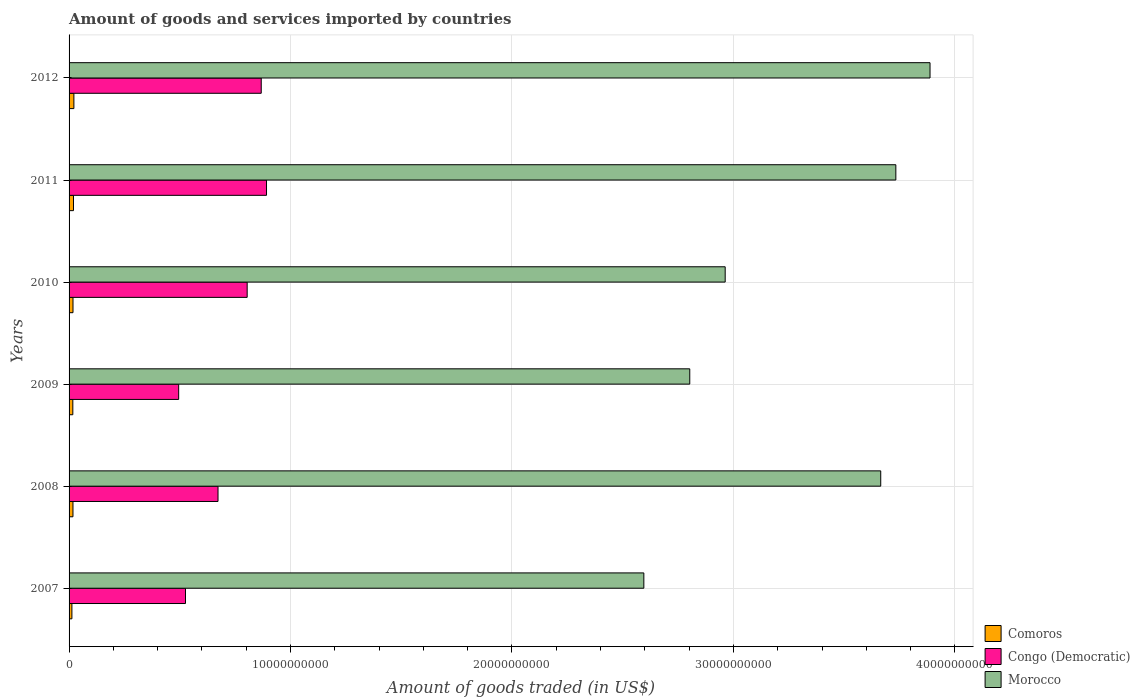Are the number of bars per tick equal to the number of legend labels?
Offer a terse response. Yes. Are the number of bars on each tick of the Y-axis equal?
Offer a very short reply. Yes. How many bars are there on the 5th tick from the bottom?
Your answer should be very brief. 3. In how many cases, is the number of bars for a given year not equal to the number of legend labels?
Give a very brief answer. 0. What is the total amount of goods and services imported in Comoros in 2012?
Make the answer very short. 2.18e+08. Across all years, what is the maximum total amount of goods and services imported in Comoros?
Your answer should be very brief. 2.18e+08. Across all years, what is the minimum total amount of goods and services imported in Morocco?
Offer a very short reply. 2.60e+1. In which year was the total amount of goods and services imported in Congo (Democratic) minimum?
Offer a terse response. 2009. What is the total total amount of goods and services imported in Morocco in the graph?
Your answer should be very brief. 1.96e+11. What is the difference between the total amount of goods and services imported in Morocco in 2009 and that in 2011?
Your answer should be very brief. -9.31e+09. What is the difference between the total amount of goods and services imported in Congo (Democratic) in 2009 and the total amount of goods and services imported in Comoros in 2008?
Offer a very short reply. 4.77e+09. What is the average total amount of goods and services imported in Morocco per year?
Ensure brevity in your answer.  3.27e+1. In the year 2011, what is the difference between the total amount of goods and services imported in Congo (Democratic) and total amount of goods and services imported in Morocco?
Provide a succinct answer. -2.84e+1. In how many years, is the total amount of goods and services imported in Morocco greater than 14000000000 US$?
Ensure brevity in your answer.  6. What is the ratio of the total amount of goods and services imported in Morocco in 2009 to that in 2010?
Make the answer very short. 0.95. What is the difference between the highest and the second highest total amount of goods and services imported in Congo (Democratic)?
Ensure brevity in your answer.  2.38e+08. What is the difference between the highest and the lowest total amount of goods and services imported in Morocco?
Your response must be concise. 1.29e+1. In how many years, is the total amount of goods and services imported in Morocco greater than the average total amount of goods and services imported in Morocco taken over all years?
Ensure brevity in your answer.  3. What does the 2nd bar from the top in 2012 represents?
Your answer should be very brief. Congo (Democratic). What does the 1st bar from the bottom in 2008 represents?
Keep it short and to the point. Comoros. How many bars are there?
Your answer should be very brief. 18. Are the values on the major ticks of X-axis written in scientific E-notation?
Offer a terse response. No. Does the graph contain any zero values?
Provide a short and direct response. No. Does the graph contain grids?
Keep it short and to the point. Yes. How many legend labels are there?
Give a very brief answer. 3. How are the legend labels stacked?
Offer a terse response. Vertical. What is the title of the graph?
Make the answer very short. Amount of goods and services imported by countries. What is the label or title of the X-axis?
Offer a very short reply. Amount of goods traded (in US$). What is the Amount of goods traded (in US$) in Comoros in 2007?
Your response must be concise. 1.28e+08. What is the Amount of goods traded (in US$) of Congo (Democratic) in 2007?
Keep it short and to the point. 5.26e+09. What is the Amount of goods traded (in US$) in Morocco in 2007?
Your response must be concise. 2.60e+1. What is the Amount of goods traded (in US$) in Comoros in 2008?
Your answer should be compact. 1.76e+08. What is the Amount of goods traded (in US$) of Congo (Democratic) in 2008?
Your response must be concise. 6.73e+09. What is the Amount of goods traded (in US$) in Morocco in 2008?
Your answer should be very brief. 3.67e+1. What is the Amount of goods traded (in US$) of Comoros in 2009?
Offer a terse response. 1.70e+08. What is the Amount of goods traded (in US$) in Congo (Democratic) in 2009?
Offer a very short reply. 4.95e+09. What is the Amount of goods traded (in US$) in Morocco in 2009?
Keep it short and to the point. 2.80e+1. What is the Amount of goods traded (in US$) in Comoros in 2010?
Offer a terse response. 1.77e+08. What is the Amount of goods traded (in US$) in Congo (Democratic) in 2010?
Provide a short and direct response. 8.04e+09. What is the Amount of goods traded (in US$) in Morocco in 2010?
Make the answer very short. 2.96e+1. What is the Amount of goods traded (in US$) in Comoros in 2011?
Ensure brevity in your answer.  1.99e+08. What is the Amount of goods traded (in US$) in Congo (Democratic) in 2011?
Offer a terse response. 8.92e+09. What is the Amount of goods traded (in US$) in Morocco in 2011?
Your answer should be compact. 3.73e+1. What is the Amount of goods traded (in US$) in Comoros in 2012?
Your answer should be compact. 2.18e+08. What is the Amount of goods traded (in US$) of Congo (Democratic) in 2012?
Your response must be concise. 8.68e+09. What is the Amount of goods traded (in US$) in Morocco in 2012?
Offer a terse response. 3.89e+1. Across all years, what is the maximum Amount of goods traded (in US$) of Comoros?
Offer a terse response. 2.18e+08. Across all years, what is the maximum Amount of goods traded (in US$) of Congo (Democratic)?
Provide a short and direct response. 8.92e+09. Across all years, what is the maximum Amount of goods traded (in US$) in Morocco?
Keep it short and to the point. 3.89e+1. Across all years, what is the minimum Amount of goods traded (in US$) of Comoros?
Provide a succinct answer. 1.28e+08. Across all years, what is the minimum Amount of goods traded (in US$) in Congo (Democratic)?
Provide a short and direct response. 4.95e+09. Across all years, what is the minimum Amount of goods traded (in US$) in Morocco?
Make the answer very short. 2.60e+1. What is the total Amount of goods traded (in US$) in Comoros in the graph?
Provide a succinct answer. 1.07e+09. What is the total Amount of goods traded (in US$) in Congo (Democratic) in the graph?
Offer a very short reply. 4.26e+1. What is the total Amount of goods traded (in US$) in Morocco in the graph?
Offer a very short reply. 1.96e+11. What is the difference between the Amount of goods traded (in US$) of Comoros in 2007 and that in 2008?
Give a very brief answer. -4.80e+07. What is the difference between the Amount of goods traded (in US$) of Congo (Democratic) in 2007 and that in 2008?
Provide a succinct answer. -1.47e+09. What is the difference between the Amount of goods traded (in US$) in Morocco in 2007 and that in 2008?
Ensure brevity in your answer.  -1.07e+1. What is the difference between the Amount of goods traded (in US$) in Comoros in 2007 and that in 2009?
Your answer should be compact. -4.17e+07. What is the difference between the Amount of goods traded (in US$) of Congo (Democratic) in 2007 and that in 2009?
Give a very brief answer. 3.08e+08. What is the difference between the Amount of goods traded (in US$) of Morocco in 2007 and that in 2009?
Offer a very short reply. -2.07e+09. What is the difference between the Amount of goods traded (in US$) in Comoros in 2007 and that in 2010?
Offer a terse response. -4.95e+07. What is the difference between the Amount of goods traded (in US$) in Congo (Democratic) in 2007 and that in 2010?
Make the answer very short. -2.79e+09. What is the difference between the Amount of goods traded (in US$) of Morocco in 2007 and that in 2010?
Offer a terse response. -3.67e+09. What is the difference between the Amount of goods traded (in US$) of Comoros in 2007 and that in 2011?
Offer a very short reply. -7.16e+07. What is the difference between the Amount of goods traded (in US$) of Congo (Democratic) in 2007 and that in 2011?
Give a very brief answer. -3.66e+09. What is the difference between the Amount of goods traded (in US$) in Morocco in 2007 and that in 2011?
Offer a very short reply. -1.14e+1. What is the difference between the Amount of goods traded (in US$) in Comoros in 2007 and that in 2012?
Give a very brief answer. -9.00e+07. What is the difference between the Amount of goods traded (in US$) in Congo (Democratic) in 2007 and that in 2012?
Your response must be concise. -3.42e+09. What is the difference between the Amount of goods traded (in US$) of Morocco in 2007 and that in 2012?
Provide a short and direct response. -1.29e+1. What is the difference between the Amount of goods traded (in US$) of Comoros in 2008 and that in 2009?
Provide a short and direct response. 6.33e+06. What is the difference between the Amount of goods traded (in US$) in Congo (Democratic) in 2008 and that in 2009?
Make the answer very short. 1.78e+09. What is the difference between the Amount of goods traded (in US$) in Morocco in 2008 and that in 2009?
Offer a very short reply. 8.62e+09. What is the difference between the Amount of goods traded (in US$) in Comoros in 2008 and that in 2010?
Offer a terse response. -1.45e+06. What is the difference between the Amount of goods traded (in US$) in Congo (Democratic) in 2008 and that in 2010?
Make the answer very short. -1.32e+09. What is the difference between the Amount of goods traded (in US$) of Morocco in 2008 and that in 2010?
Your response must be concise. 7.02e+09. What is the difference between the Amount of goods traded (in US$) in Comoros in 2008 and that in 2011?
Provide a succinct answer. -2.36e+07. What is the difference between the Amount of goods traded (in US$) in Congo (Democratic) in 2008 and that in 2011?
Offer a very short reply. -2.19e+09. What is the difference between the Amount of goods traded (in US$) of Morocco in 2008 and that in 2011?
Provide a short and direct response. -6.82e+08. What is the difference between the Amount of goods traded (in US$) of Comoros in 2008 and that in 2012?
Ensure brevity in your answer.  -4.20e+07. What is the difference between the Amount of goods traded (in US$) in Congo (Democratic) in 2008 and that in 2012?
Offer a terse response. -1.95e+09. What is the difference between the Amount of goods traded (in US$) in Morocco in 2008 and that in 2012?
Give a very brief answer. -2.23e+09. What is the difference between the Amount of goods traded (in US$) of Comoros in 2009 and that in 2010?
Provide a succinct answer. -7.79e+06. What is the difference between the Amount of goods traded (in US$) in Congo (Democratic) in 2009 and that in 2010?
Your answer should be compact. -3.09e+09. What is the difference between the Amount of goods traded (in US$) in Morocco in 2009 and that in 2010?
Provide a succinct answer. -1.60e+09. What is the difference between the Amount of goods traded (in US$) in Comoros in 2009 and that in 2011?
Make the answer very short. -2.99e+07. What is the difference between the Amount of goods traded (in US$) in Congo (Democratic) in 2009 and that in 2011?
Offer a very short reply. -3.97e+09. What is the difference between the Amount of goods traded (in US$) of Morocco in 2009 and that in 2011?
Keep it short and to the point. -9.31e+09. What is the difference between the Amount of goods traded (in US$) of Comoros in 2009 and that in 2012?
Offer a terse response. -4.83e+07. What is the difference between the Amount of goods traded (in US$) of Congo (Democratic) in 2009 and that in 2012?
Offer a very short reply. -3.73e+09. What is the difference between the Amount of goods traded (in US$) of Morocco in 2009 and that in 2012?
Provide a short and direct response. -1.08e+1. What is the difference between the Amount of goods traded (in US$) in Comoros in 2010 and that in 2011?
Offer a terse response. -2.21e+07. What is the difference between the Amount of goods traded (in US$) in Congo (Democratic) in 2010 and that in 2011?
Your answer should be very brief. -8.73e+08. What is the difference between the Amount of goods traded (in US$) of Morocco in 2010 and that in 2011?
Keep it short and to the point. -7.71e+09. What is the difference between the Amount of goods traded (in US$) of Comoros in 2010 and that in 2012?
Keep it short and to the point. -4.05e+07. What is the difference between the Amount of goods traded (in US$) in Congo (Democratic) in 2010 and that in 2012?
Offer a terse response. -6.35e+08. What is the difference between the Amount of goods traded (in US$) in Morocco in 2010 and that in 2012?
Make the answer very short. -9.25e+09. What is the difference between the Amount of goods traded (in US$) in Comoros in 2011 and that in 2012?
Your response must be concise. -1.84e+07. What is the difference between the Amount of goods traded (in US$) of Congo (Democratic) in 2011 and that in 2012?
Provide a short and direct response. 2.38e+08. What is the difference between the Amount of goods traded (in US$) in Morocco in 2011 and that in 2012?
Ensure brevity in your answer.  -1.54e+09. What is the difference between the Amount of goods traded (in US$) of Comoros in 2007 and the Amount of goods traded (in US$) of Congo (Democratic) in 2008?
Provide a succinct answer. -6.60e+09. What is the difference between the Amount of goods traded (in US$) in Comoros in 2007 and the Amount of goods traded (in US$) in Morocco in 2008?
Keep it short and to the point. -3.65e+1. What is the difference between the Amount of goods traded (in US$) in Congo (Democratic) in 2007 and the Amount of goods traded (in US$) in Morocco in 2008?
Your answer should be very brief. -3.14e+1. What is the difference between the Amount of goods traded (in US$) in Comoros in 2007 and the Amount of goods traded (in US$) in Congo (Democratic) in 2009?
Offer a very short reply. -4.82e+09. What is the difference between the Amount of goods traded (in US$) of Comoros in 2007 and the Amount of goods traded (in US$) of Morocco in 2009?
Your response must be concise. -2.79e+1. What is the difference between the Amount of goods traded (in US$) in Congo (Democratic) in 2007 and the Amount of goods traded (in US$) in Morocco in 2009?
Offer a terse response. -2.28e+1. What is the difference between the Amount of goods traded (in US$) of Comoros in 2007 and the Amount of goods traded (in US$) of Congo (Democratic) in 2010?
Provide a short and direct response. -7.91e+09. What is the difference between the Amount of goods traded (in US$) in Comoros in 2007 and the Amount of goods traded (in US$) in Morocco in 2010?
Your answer should be compact. -2.95e+1. What is the difference between the Amount of goods traded (in US$) of Congo (Democratic) in 2007 and the Amount of goods traded (in US$) of Morocco in 2010?
Give a very brief answer. -2.44e+1. What is the difference between the Amount of goods traded (in US$) of Comoros in 2007 and the Amount of goods traded (in US$) of Congo (Democratic) in 2011?
Provide a succinct answer. -8.79e+09. What is the difference between the Amount of goods traded (in US$) of Comoros in 2007 and the Amount of goods traded (in US$) of Morocco in 2011?
Your response must be concise. -3.72e+1. What is the difference between the Amount of goods traded (in US$) in Congo (Democratic) in 2007 and the Amount of goods traded (in US$) in Morocco in 2011?
Ensure brevity in your answer.  -3.21e+1. What is the difference between the Amount of goods traded (in US$) in Comoros in 2007 and the Amount of goods traded (in US$) in Congo (Democratic) in 2012?
Make the answer very short. -8.55e+09. What is the difference between the Amount of goods traded (in US$) of Comoros in 2007 and the Amount of goods traded (in US$) of Morocco in 2012?
Offer a very short reply. -3.87e+1. What is the difference between the Amount of goods traded (in US$) of Congo (Democratic) in 2007 and the Amount of goods traded (in US$) of Morocco in 2012?
Your response must be concise. -3.36e+1. What is the difference between the Amount of goods traded (in US$) in Comoros in 2008 and the Amount of goods traded (in US$) in Congo (Democratic) in 2009?
Your answer should be compact. -4.77e+09. What is the difference between the Amount of goods traded (in US$) in Comoros in 2008 and the Amount of goods traded (in US$) in Morocco in 2009?
Your answer should be compact. -2.79e+1. What is the difference between the Amount of goods traded (in US$) of Congo (Democratic) in 2008 and the Amount of goods traded (in US$) of Morocco in 2009?
Ensure brevity in your answer.  -2.13e+1. What is the difference between the Amount of goods traded (in US$) of Comoros in 2008 and the Amount of goods traded (in US$) of Congo (Democratic) in 2010?
Your answer should be compact. -7.87e+09. What is the difference between the Amount of goods traded (in US$) in Comoros in 2008 and the Amount of goods traded (in US$) in Morocco in 2010?
Your answer should be very brief. -2.95e+1. What is the difference between the Amount of goods traded (in US$) of Congo (Democratic) in 2008 and the Amount of goods traded (in US$) of Morocco in 2010?
Give a very brief answer. -2.29e+1. What is the difference between the Amount of goods traded (in US$) in Comoros in 2008 and the Amount of goods traded (in US$) in Congo (Democratic) in 2011?
Your answer should be compact. -8.74e+09. What is the difference between the Amount of goods traded (in US$) of Comoros in 2008 and the Amount of goods traded (in US$) of Morocco in 2011?
Ensure brevity in your answer.  -3.72e+1. What is the difference between the Amount of goods traded (in US$) in Congo (Democratic) in 2008 and the Amount of goods traded (in US$) in Morocco in 2011?
Your answer should be compact. -3.06e+1. What is the difference between the Amount of goods traded (in US$) in Comoros in 2008 and the Amount of goods traded (in US$) in Congo (Democratic) in 2012?
Your answer should be very brief. -8.50e+09. What is the difference between the Amount of goods traded (in US$) of Comoros in 2008 and the Amount of goods traded (in US$) of Morocco in 2012?
Ensure brevity in your answer.  -3.87e+1. What is the difference between the Amount of goods traded (in US$) of Congo (Democratic) in 2008 and the Amount of goods traded (in US$) of Morocco in 2012?
Your answer should be compact. -3.22e+1. What is the difference between the Amount of goods traded (in US$) of Comoros in 2009 and the Amount of goods traded (in US$) of Congo (Democratic) in 2010?
Ensure brevity in your answer.  -7.87e+09. What is the difference between the Amount of goods traded (in US$) of Comoros in 2009 and the Amount of goods traded (in US$) of Morocco in 2010?
Your answer should be compact. -2.95e+1. What is the difference between the Amount of goods traded (in US$) of Congo (Democratic) in 2009 and the Amount of goods traded (in US$) of Morocco in 2010?
Provide a succinct answer. -2.47e+1. What is the difference between the Amount of goods traded (in US$) in Comoros in 2009 and the Amount of goods traded (in US$) in Congo (Democratic) in 2011?
Your response must be concise. -8.75e+09. What is the difference between the Amount of goods traded (in US$) in Comoros in 2009 and the Amount of goods traded (in US$) in Morocco in 2011?
Give a very brief answer. -3.72e+1. What is the difference between the Amount of goods traded (in US$) of Congo (Democratic) in 2009 and the Amount of goods traded (in US$) of Morocco in 2011?
Provide a succinct answer. -3.24e+1. What is the difference between the Amount of goods traded (in US$) of Comoros in 2009 and the Amount of goods traded (in US$) of Congo (Democratic) in 2012?
Keep it short and to the point. -8.51e+09. What is the difference between the Amount of goods traded (in US$) of Comoros in 2009 and the Amount of goods traded (in US$) of Morocco in 2012?
Give a very brief answer. -3.87e+1. What is the difference between the Amount of goods traded (in US$) of Congo (Democratic) in 2009 and the Amount of goods traded (in US$) of Morocco in 2012?
Ensure brevity in your answer.  -3.39e+1. What is the difference between the Amount of goods traded (in US$) of Comoros in 2010 and the Amount of goods traded (in US$) of Congo (Democratic) in 2011?
Give a very brief answer. -8.74e+09. What is the difference between the Amount of goods traded (in US$) in Comoros in 2010 and the Amount of goods traded (in US$) in Morocco in 2011?
Provide a short and direct response. -3.72e+1. What is the difference between the Amount of goods traded (in US$) in Congo (Democratic) in 2010 and the Amount of goods traded (in US$) in Morocco in 2011?
Keep it short and to the point. -2.93e+1. What is the difference between the Amount of goods traded (in US$) of Comoros in 2010 and the Amount of goods traded (in US$) of Congo (Democratic) in 2012?
Your answer should be compact. -8.50e+09. What is the difference between the Amount of goods traded (in US$) of Comoros in 2010 and the Amount of goods traded (in US$) of Morocco in 2012?
Provide a succinct answer. -3.87e+1. What is the difference between the Amount of goods traded (in US$) in Congo (Democratic) in 2010 and the Amount of goods traded (in US$) in Morocco in 2012?
Your answer should be compact. -3.08e+1. What is the difference between the Amount of goods traded (in US$) of Comoros in 2011 and the Amount of goods traded (in US$) of Congo (Democratic) in 2012?
Offer a very short reply. -8.48e+09. What is the difference between the Amount of goods traded (in US$) in Comoros in 2011 and the Amount of goods traded (in US$) in Morocco in 2012?
Make the answer very short. -3.87e+1. What is the difference between the Amount of goods traded (in US$) in Congo (Democratic) in 2011 and the Amount of goods traded (in US$) in Morocco in 2012?
Keep it short and to the point. -3.00e+1. What is the average Amount of goods traded (in US$) in Comoros per year?
Your response must be concise. 1.78e+08. What is the average Amount of goods traded (in US$) of Congo (Democratic) per year?
Give a very brief answer. 7.09e+09. What is the average Amount of goods traded (in US$) in Morocco per year?
Give a very brief answer. 3.27e+1. In the year 2007, what is the difference between the Amount of goods traded (in US$) of Comoros and Amount of goods traded (in US$) of Congo (Democratic)?
Provide a succinct answer. -5.13e+09. In the year 2007, what is the difference between the Amount of goods traded (in US$) of Comoros and Amount of goods traded (in US$) of Morocco?
Ensure brevity in your answer.  -2.58e+1. In the year 2007, what is the difference between the Amount of goods traded (in US$) of Congo (Democratic) and Amount of goods traded (in US$) of Morocco?
Provide a short and direct response. -2.07e+1. In the year 2008, what is the difference between the Amount of goods traded (in US$) in Comoros and Amount of goods traded (in US$) in Congo (Democratic)?
Make the answer very short. -6.55e+09. In the year 2008, what is the difference between the Amount of goods traded (in US$) of Comoros and Amount of goods traded (in US$) of Morocco?
Keep it short and to the point. -3.65e+1. In the year 2008, what is the difference between the Amount of goods traded (in US$) in Congo (Democratic) and Amount of goods traded (in US$) in Morocco?
Ensure brevity in your answer.  -2.99e+1. In the year 2009, what is the difference between the Amount of goods traded (in US$) in Comoros and Amount of goods traded (in US$) in Congo (Democratic)?
Your answer should be very brief. -4.78e+09. In the year 2009, what is the difference between the Amount of goods traded (in US$) in Comoros and Amount of goods traded (in US$) in Morocco?
Keep it short and to the point. -2.79e+1. In the year 2009, what is the difference between the Amount of goods traded (in US$) of Congo (Democratic) and Amount of goods traded (in US$) of Morocco?
Offer a terse response. -2.31e+1. In the year 2010, what is the difference between the Amount of goods traded (in US$) in Comoros and Amount of goods traded (in US$) in Congo (Democratic)?
Your answer should be very brief. -7.87e+09. In the year 2010, what is the difference between the Amount of goods traded (in US$) in Comoros and Amount of goods traded (in US$) in Morocco?
Make the answer very short. -2.94e+1. In the year 2010, what is the difference between the Amount of goods traded (in US$) of Congo (Democratic) and Amount of goods traded (in US$) of Morocco?
Your answer should be very brief. -2.16e+1. In the year 2011, what is the difference between the Amount of goods traded (in US$) of Comoros and Amount of goods traded (in US$) of Congo (Democratic)?
Your response must be concise. -8.72e+09. In the year 2011, what is the difference between the Amount of goods traded (in US$) in Comoros and Amount of goods traded (in US$) in Morocco?
Ensure brevity in your answer.  -3.71e+1. In the year 2011, what is the difference between the Amount of goods traded (in US$) in Congo (Democratic) and Amount of goods traded (in US$) in Morocco?
Give a very brief answer. -2.84e+1. In the year 2012, what is the difference between the Amount of goods traded (in US$) in Comoros and Amount of goods traded (in US$) in Congo (Democratic)?
Make the answer very short. -8.46e+09. In the year 2012, what is the difference between the Amount of goods traded (in US$) in Comoros and Amount of goods traded (in US$) in Morocco?
Your answer should be compact. -3.87e+1. In the year 2012, what is the difference between the Amount of goods traded (in US$) in Congo (Democratic) and Amount of goods traded (in US$) in Morocco?
Your response must be concise. -3.02e+1. What is the ratio of the Amount of goods traded (in US$) in Comoros in 2007 to that in 2008?
Your answer should be very brief. 0.73. What is the ratio of the Amount of goods traded (in US$) in Congo (Democratic) in 2007 to that in 2008?
Ensure brevity in your answer.  0.78. What is the ratio of the Amount of goods traded (in US$) in Morocco in 2007 to that in 2008?
Provide a succinct answer. 0.71. What is the ratio of the Amount of goods traded (in US$) of Comoros in 2007 to that in 2009?
Make the answer very short. 0.75. What is the ratio of the Amount of goods traded (in US$) of Congo (Democratic) in 2007 to that in 2009?
Offer a terse response. 1.06. What is the ratio of the Amount of goods traded (in US$) of Morocco in 2007 to that in 2009?
Your answer should be very brief. 0.93. What is the ratio of the Amount of goods traded (in US$) in Comoros in 2007 to that in 2010?
Your answer should be very brief. 0.72. What is the ratio of the Amount of goods traded (in US$) of Congo (Democratic) in 2007 to that in 2010?
Provide a succinct answer. 0.65. What is the ratio of the Amount of goods traded (in US$) of Morocco in 2007 to that in 2010?
Keep it short and to the point. 0.88. What is the ratio of the Amount of goods traded (in US$) in Comoros in 2007 to that in 2011?
Make the answer very short. 0.64. What is the ratio of the Amount of goods traded (in US$) of Congo (Democratic) in 2007 to that in 2011?
Your response must be concise. 0.59. What is the ratio of the Amount of goods traded (in US$) of Morocco in 2007 to that in 2011?
Your answer should be compact. 0.7. What is the ratio of the Amount of goods traded (in US$) of Comoros in 2007 to that in 2012?
Keep it short and to the point. 0.59. What is the ratio of the Amount of goods traded (in US$) in Congo (Democratic) in 2007 to that in 2012?
Offer a very short reply. 0.61. What is the ratio of the Amount of goods traded (in US$) in Morocco in 2007 to that in 2012?
Give a very brief answer. 0.67. What is the ratio of the Amount of goods traded (in US$) of Comoros in 2008 to that in 2009?
Offer a terse response. 1.04. What is the ratio of the Amount of goods traded (in US$) of Congo (Democratic) in 2008 to that in 2009?
Your answer should be compact. 1.36. What is the ratio of the Amount of goods traded (in US$) in Morocco in 2008 to that in 2009?
Your response must be concise. 1.31. What is the ratio of the Amount of goods traded (in US$) in Congo (Democratic) in 2008 to that in 2010?
Your answer should be very brief. 0.84. What is the ratio of the Amount of goods traded (in US$) of Morocco in 2008 to that in 2010?
Offer a very short reply. 1.24. What is the ratio of the Amount of goods traded (in US$) of Comoros in 2008 to that in 2011?
Keep it short and to the point. 0.88. What is the ratio of the Amount of goods traded (in US$) of Congo (Democratic) in 2008 to that in 2011?
Give a very brief answer. 0.75. What is the ratio of the Amount of goods traded (in US$) in Morocco in 2008 to that in 2011?
Your response must be concise. 0.98. What is the ratio of the Amount of goods traded (in US$) in Comoros in 2008 to that in 2012?
Your answer should be very brief. 0.81. What is the ratio of the Amount of goods traded (in US$) of Congo (Democratic) in 2008 to that in 2012?
Offer a terse response. 0.78. What is the ratio of the Amount of goods traded (in US$) of Morocco in 2008 to that in 2012?
Make the answer very short. 0.94. What is the ratio of the Amount of goods traded (in US$) in Comoros in 2009 to that in 2010?
Give a very brief answer. 0.96. What is the ratio of the Amount of goods traded (in US$) in Congo (Democratic) in 2009 to that in 2010?
Offer a very short reply. 0.62. What is the ratio of the Amount of goods traded (in US$) of Morocco in 2009 to that in 2010?
Offer a very short reply. 0.95. What is the ratio of the Amount of goods traded (in US$) in Comoros in 2009 to that in 2011?
Offer a very short reply. 0.85. What is the ratio of the Amount of goods traded (in US$) of Congo (Democratic) in 2009 to that in 2011?
Ensure brevity in your answer.  0.56. What is the ratio of the Amount of goods traded (in US$) of Morocco in 2009 to that in 2011?
Offer a terse response. 0.75. What is the ratio of the Amount of goods traded (in US$) of Comoros in 2009 to that in 2012?
Offer a terse response. 0.78. What is the ratio of the Amount of goods traded (in US$) in Congo (Democratic) in 2009 to that in 2012?
Make the answer very short. 0.57. What is the ratio of the Amount of goods traded (in US$) of Morocco in 2009 to that in 2012?
Offer a terse response. 0.72. What is the ratio of the Amount of goods traded (in US$) of Comoros in 2010 to that in 2011?
Offer a terse response. 0.89. What is the ratio of the Amount of goods traded (in US$) in Congo (Democratic) in 2010 to that in 2011?
Ensure brevity in your answer.  0.9. What is the ratio of the Amount of goods traded (in US$) in Morocco in 2010 to that in 2011?
Provide a short and direct response. 0.79. What is the ratio of the Amount of goods traded (in US$) of Comoros in 2010 to that in 2012?
Your answer should be compact. 0.81. What is the ratio of the Amount of goods traded (in US$) of Congo (Democratic) in 2010 to that in 2012?
Offer a very short reply. 0.93. What is the ratio of the Amount of goods traded (in US$) of Morocco in 2010 to that in 2012?
Your answer should be compact. 0.76. What is the ratio of the Amount of goods traded (in US$) of Comoros in 2011 to that in 2012?
Your response must be concise. 0.92. What is the ratio of the Amount of goods traded (in US$) in Congo (Democratic) in 2011 to that in 2012?
Your answer should be very brief. 1.03. What is the ratio of the Amount of goods traded (in US$) of Morocco in 2011 to that in 2012?
Ensure brevity in your answer.  0.96. What is the difference between the highest and the second highest Amount of goods traded (in US$) in Comoros?
Give a very brief answer. 1.84e+07. What is the difference between the highest and the second highest Amount of goods traded (in US$) in Congo (Democratic)?
Provide a succinct answer. 2.38e+08. What is the difference between the highest and the second highest Amount of goods traded (in US$) in Morocco?
Your answer should be very brief. 1.54e+09. What is the difference between the highest and the lowest Amount of goods traded (in US$) in Comoros?
Make the answer very short. 9.00e+07. What is the difference between the highest and the lowest Amount of goods traded (in US$) in Congo (Democratic)?
Your answer should be very brief. 3.97e+09. What is the difference between the highest and the lowest Amount of goods traded (in US$) of Morocco?
Offer a terse response. 1.29e+1. 